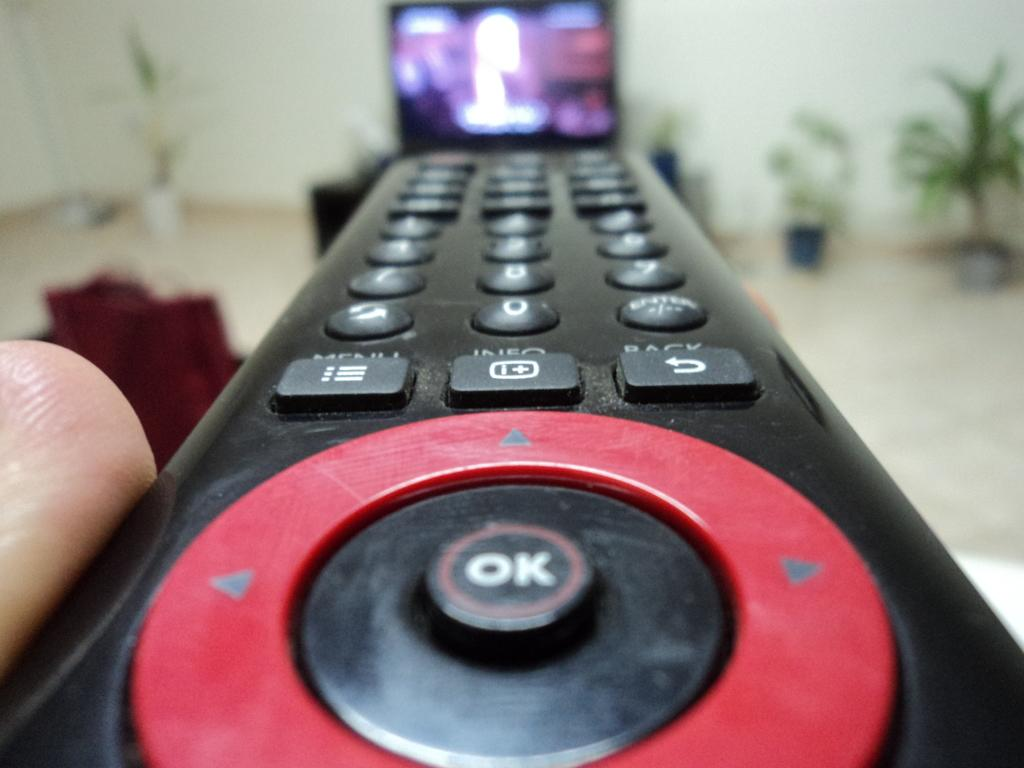<image>
Create a compact narrative representing the image presented. A person is holding a black and red remote that has a button that says OK. 